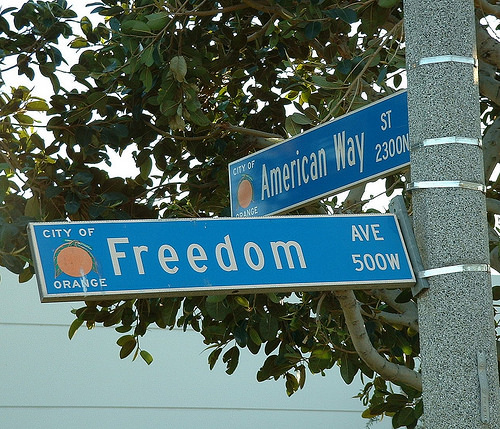<image>
Is there a board under the tree? Yes. The board is positioned underneath the tree, with the tree above it in the vertical space. 